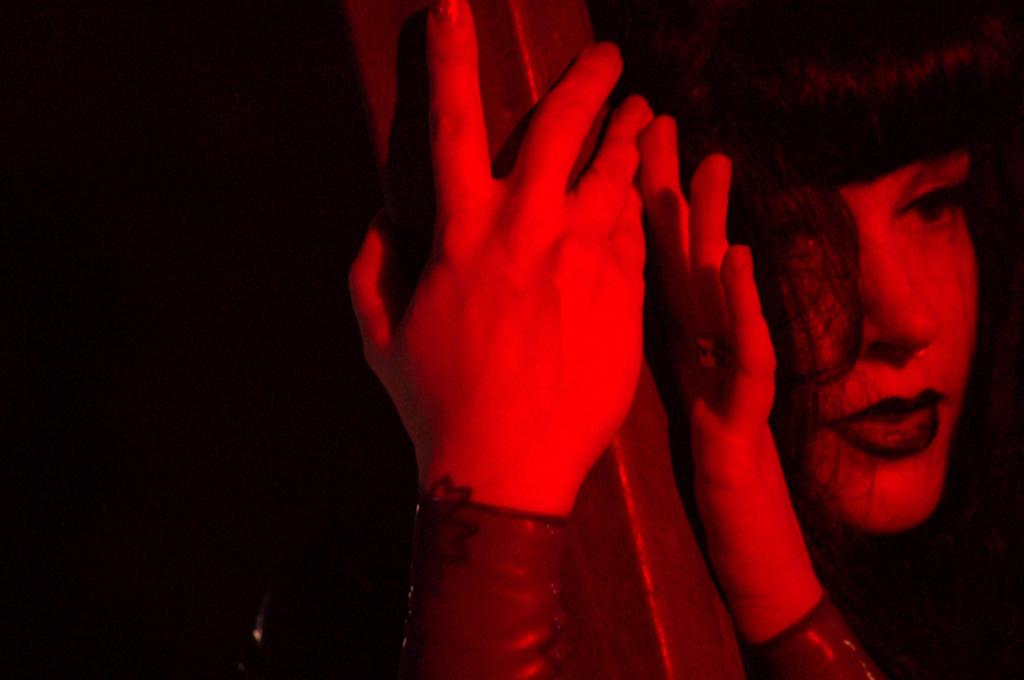What is the main subject of the image? There is a person in the image. What type of animal or creature is present in the image? There is no animal or creature present in the image; it features a person. 